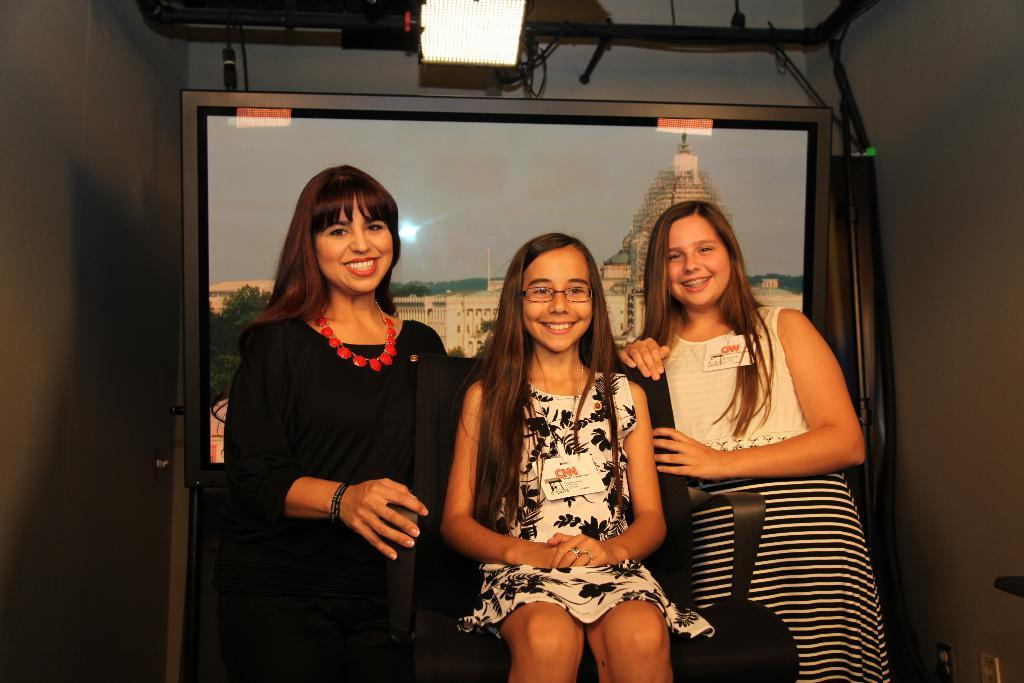How many women are in the image? There are two women in the image. What are the women doing in the image? The women are smiling and standing. What is the girl in the image doing? The girl is sitting on a chair in the image. What can be seen in the background of the image? There is light, a screen, rods, and walls in the background of the image. Can you see the sun in the image? There is no mention of the sun in the image. --- Facts: 1. There is a car in the image. 2. The car is red. 3. The car has four wheels. 4. The car has a license plate. 5. The car has a trunk. 6. The car has a windshield. Absurd Topics: bicycle Conversation: What type of vehicle is in the image? There is a car in the image. What color is the car? The car is red. How many wheels does the car have? The car has four wheels. Does the car have a license plate? Yes, the car has a license plate. Does the car have a trunk? Yes, the car has a trunk. Does the car have a windshield? Yes, the car has a windshield. Reasoning: Let's think step by step in order to produce the conversation. We start by identifying the main subject of the image, which is the car. Next, we describe specific features of the car, such as its color, the number of wheels, the presence of a license plate, a trunk, and a windshield. Then, we formulate questions that focus on the characteristics of the car, ensuring that each question can be answered definitively with the information given. We avoid yes/no questions and ensure that the language is simple and clear. Absurd Question/Answer: Can you see any bicycles in the image? There is no mention of a bicycle in the image. 